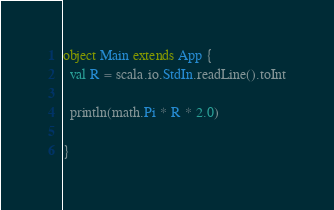<code> <loc_0><loc_0><loc_500><loc_500><_Scala_>object Main extends App {
  val R = scala.io.StdIn.readLine().toInt

  println(math.Pi * R * 2.0)

}
</code> 